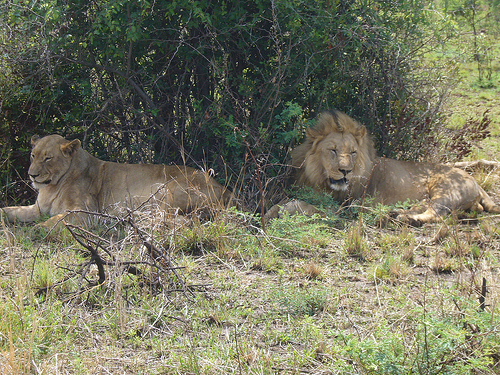<image>
Is there a lioness under the bush? Yes. The lioness is positioned underneath the bush, with the bush above it in the vertical space. 